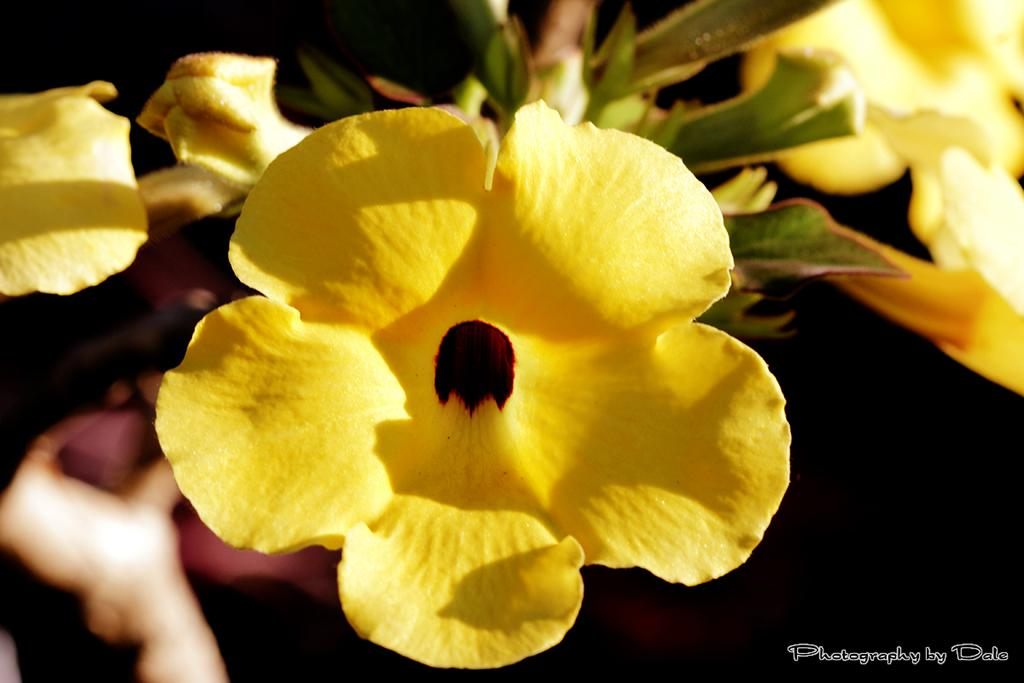What type of living organisms can be seen in the image? There are flowers in the image. What color are the flowers? The flowers are yellow. What is the color of the background in the image? The background of the image is dark. What else is present in the image besides the flowers? There is text visible in the image. What type of waste treatment facility is depicted in the image? There is no waste treatment facility present in the image; it features yellow flowers and text against a dark background. How is the oil being processed in the image? There is no oil or processing facility present in the image. 